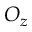Convert formula to latex. <formula><loc_0><loc_0><loc_500><loc_500>O _ { z }</formula> 